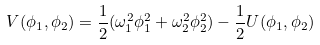<formula> <loc_0><loc_0><loc_500><loc_500>V ( \phi _ { 1 } , \phi _ { 2 } ) = \frac { 1 } { 2 } ( \omega _ { 1 } ^ { 2 } \phi _ { 1 } ^ { 2 } + \omega _ { 2 } ^ { 2 } \phi _ { 2 } ^ { 2 } ) - \frac { 1 } { 2 } U ( \phi _ { 1 } , \phi _ { 2 } )</formula> 